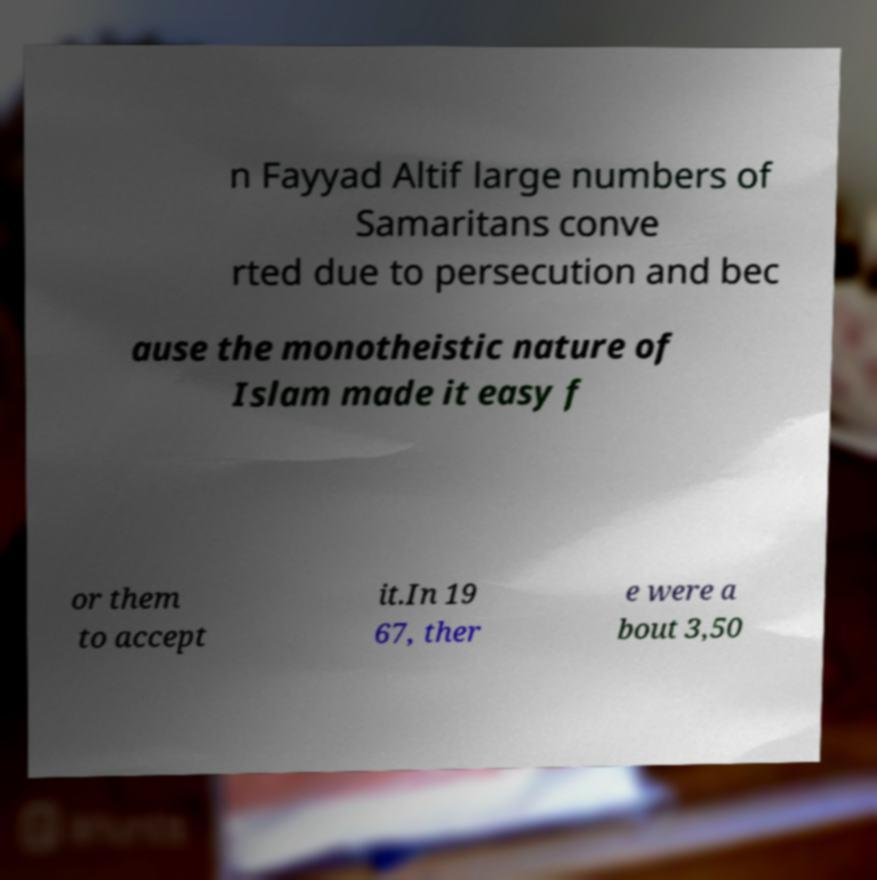I need the written content from this picture converted into text. Can you do that? n Fayyad Altif large numbers of Samaritans conve rted due to persecution and bec ause the monotheistic nature of Islam made it easy f or them to accept it.In 19 67, ther e were a bout 3,50 